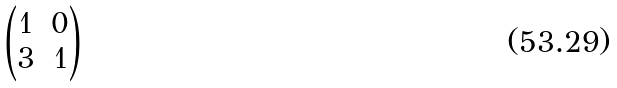Convert formula to latex. <formula><loc_0><loc_0><loc_500><loc_500>\begin{pmatrix} 1 & 0 \\ 3 & 1 \end{pmatrix}</formula> 